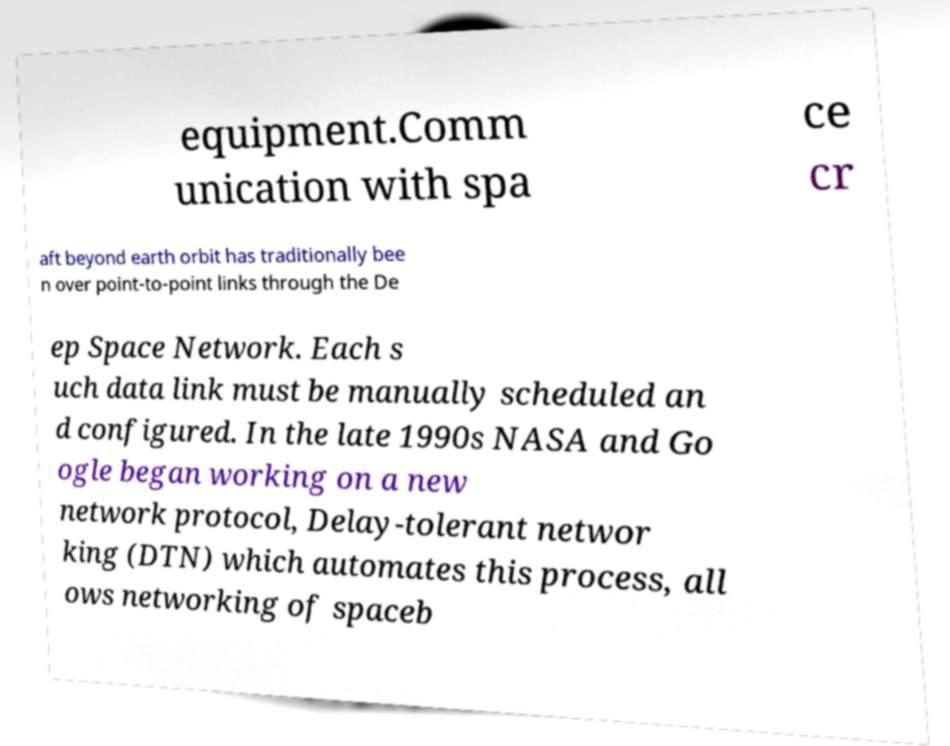Please identify and transcribe the text found in this image. equipment.Comm unication with spa ce cr aft beyond earth orbit has traditionally bee n over point-to-point links through the De ep Space Network. Each s uch data link must be manually scheduled an d configured. In the late 1990s NASA and Go ogle began working on a new network protocol, Delay-tolerant networ king (DTN) which automates this process, all ows networking of spaceb 